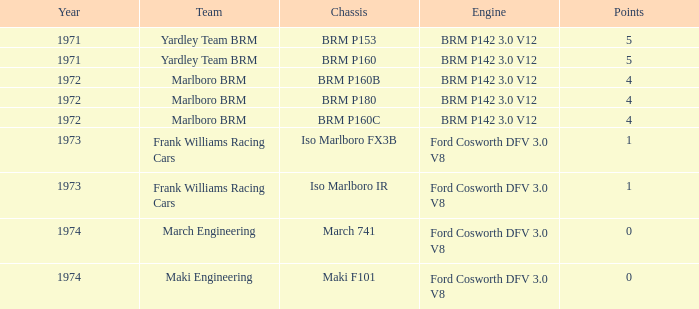What are the highest points for the team of marlboro brm with brm p180 as the chassis? 4.0. 